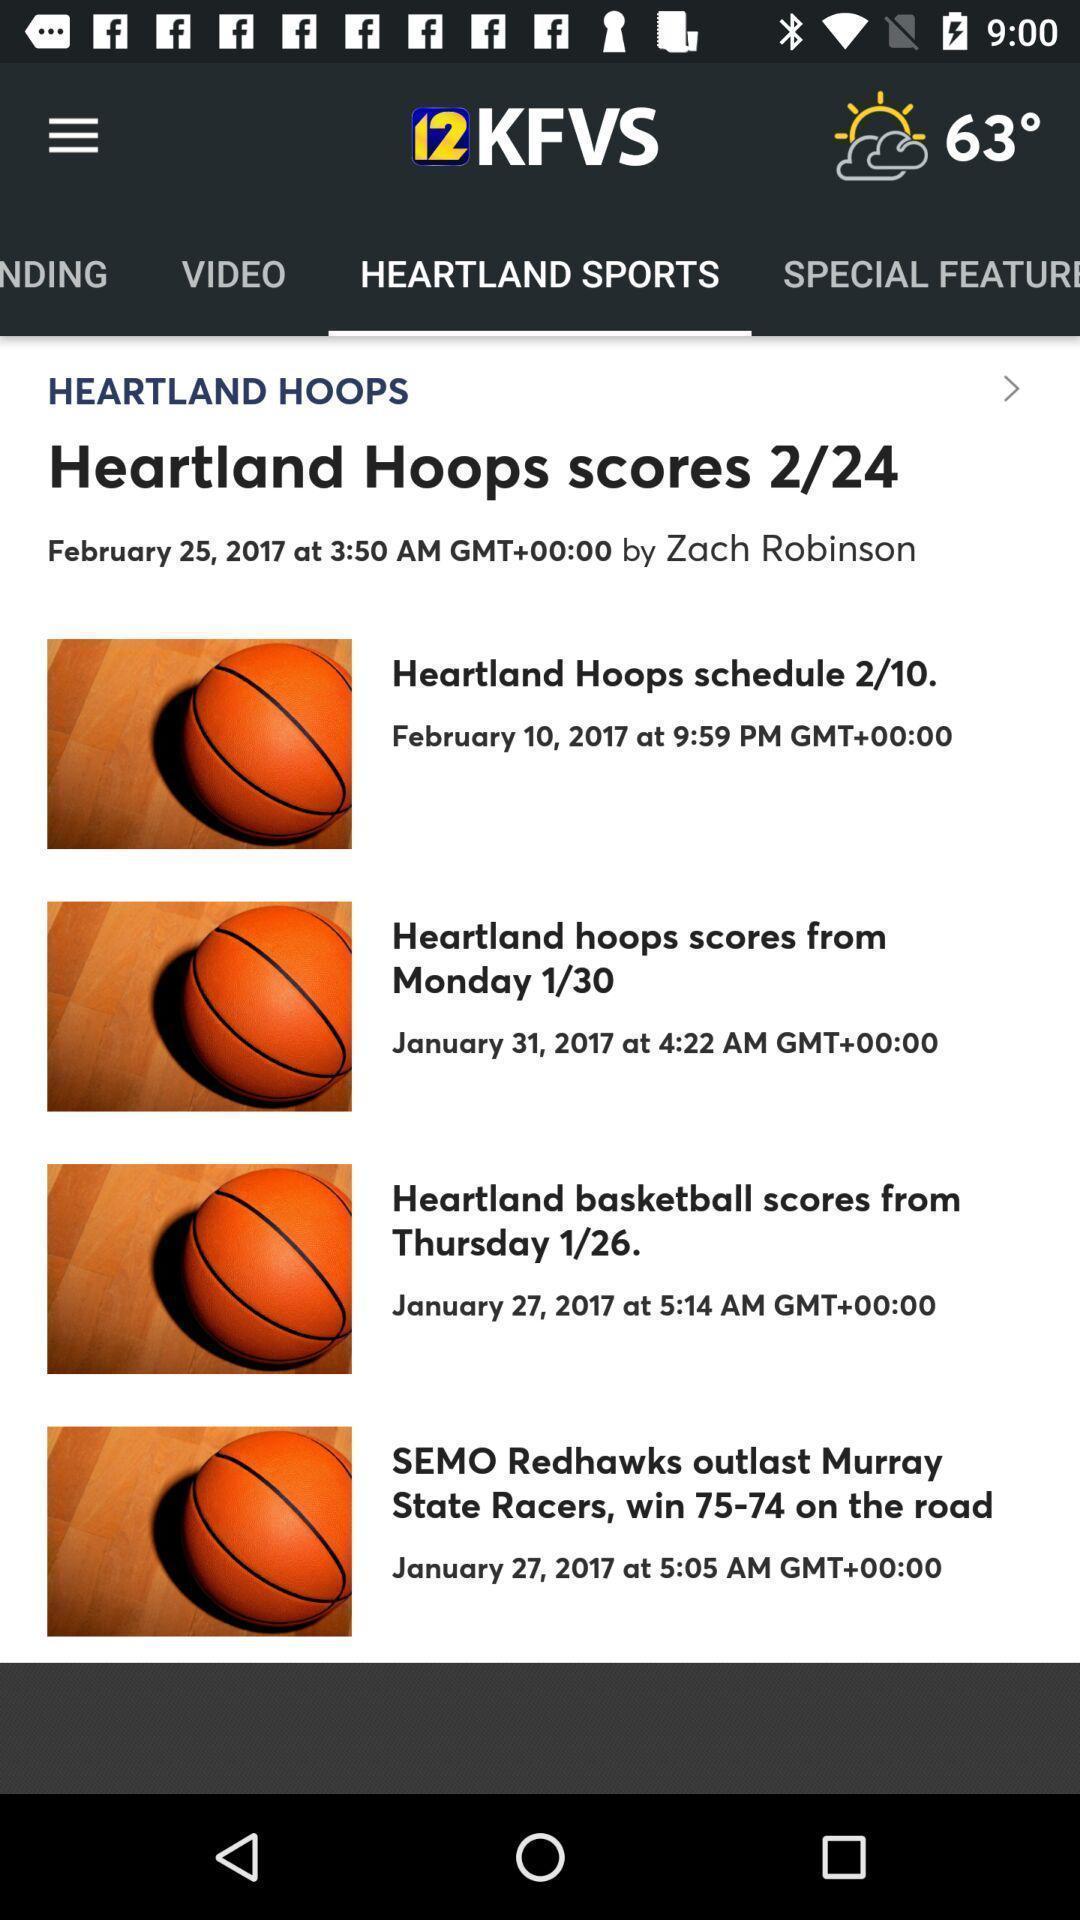Give me a narrative description of this picture. Pop-up showing information about sports. 